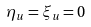<formula> <loc_0><loc_0><loc_500><loc_500>\eta _ { u } = \xi _ { u } = 0</formula> 